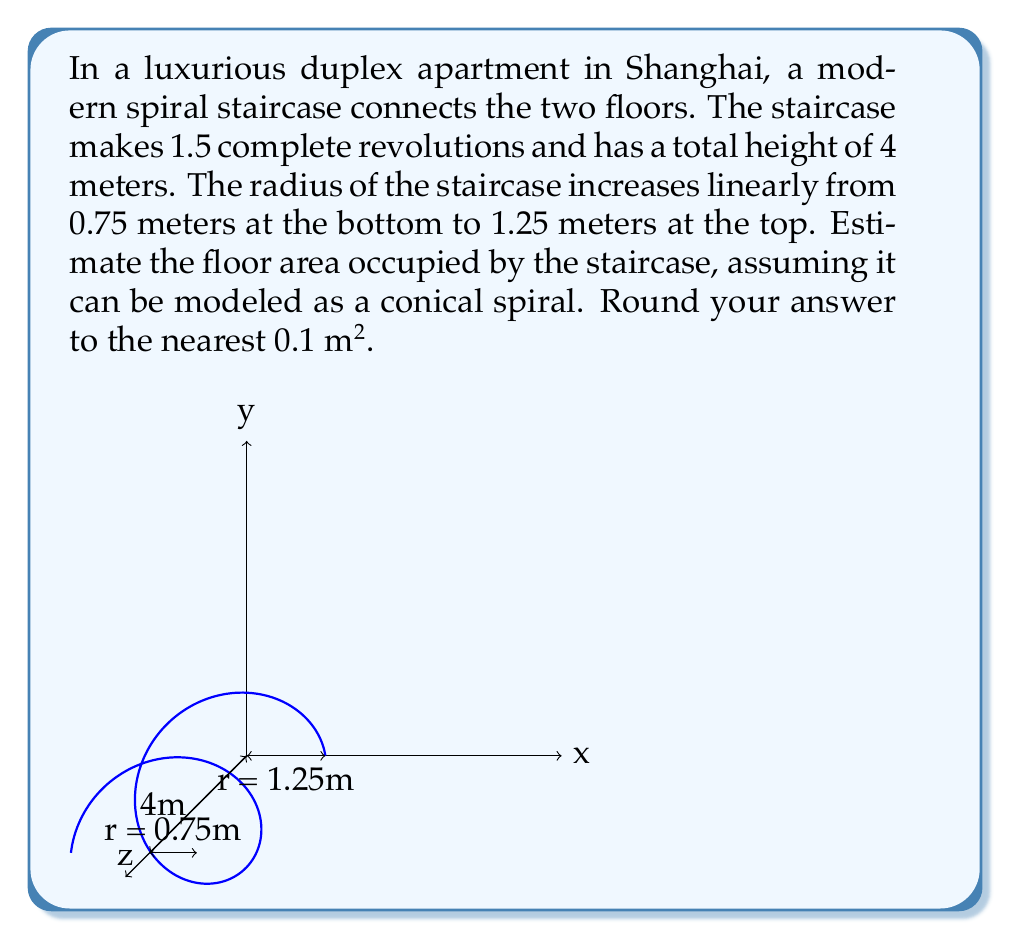Provide a solution to this math problem. To estimate the floor area occupied by the spiral staircase, we need to use polar coordinates and integration. Let's approach this step-by-step:

1) In polar coordinates, the equation of the spiral can be modeled as:
   $$r(\theta) = r_0 + k\theta$$
   where $r_0$ is the initial radius and $k$ is the rate of increase of the radius.

2) We know:
   - Initial radius, $r_0 = 0.75$ m
   - Final radius, $r_f = 1.25$ m
   - Number of revolutions, $n = 1.5$

3) The total angle swept is:
   $$\theta_{total} = 2\pi n = 2\pi(1.5) = 3\pi$$

4) We can find $k$:
   $$k = \frac{r_f - r_0}{\theta_{total}} = \frac{1.25 - 0.75}{3\pi} = \frac{1}{6\pi}$$

5) So, our spiral equation is:
   $$r(\theta) = 0.75 + \frac{\theta}{6\pi}$$

6) The area of a polar curve is given by:
   $$A = \frac{1}{2}\int_0^{\theta_{total}} r^2(\theta) d\theta$$

7) Substituting our spiral equation:
   $$A = \frac{1}{2}\int_0^{3\pi} (0.75 + \frac{\theta}{6\pi})^2 d\theta$$

8) Expanding the integrand:
   $$A = \frac{1}{2}\int_0^{3\pi} (0.5625 + \frac{0.25\theta}{2\pi} + \frac{\theta^2}{36\pi^2}) d\theta$$

9) Integrating:
   $$A = \frac{1}{2}[0.5625\theta + \frac{0.25\theta^2}{4\pi} + \frac{\theta^3}{108\pi^2}]_0^{3\pi}$$

10) Evaluating the integral:
    $$A = \frac{1}{2}[(0.5625(3\pi) + \frac{0.25(9\pi^2)}{4\pi} + \frac{27\pi^3}{108\pi^2}) - 0]$$

11) Simplifying:
    $$A \approx 4.9 \text{ m}^2$$

Rounding to the nearest 0.1 m², we get 4.9 m².
Answer: 4.9 m² 